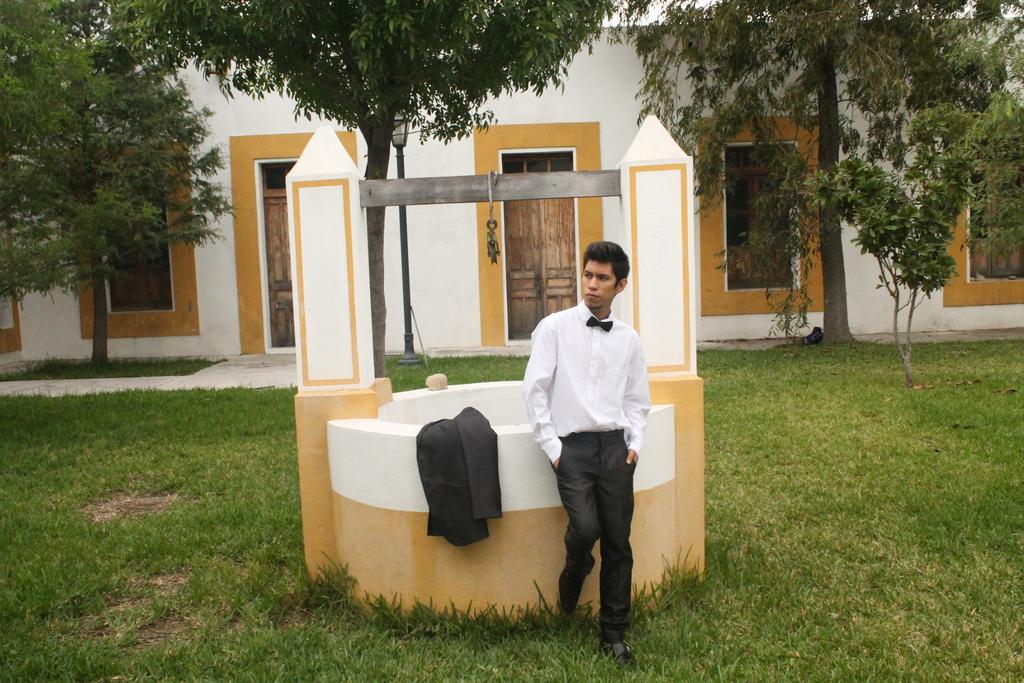What is the man in the image doing? The man is standing on the grass. What is located beside the man? The man has a jacket beside him. What can be seen in the background of the image? There are trees, light, a metal rod, and a building visible in the background. What is the sister of the man doing in the image? There is no mention of a sister in the image, so we cannot answer this question. 